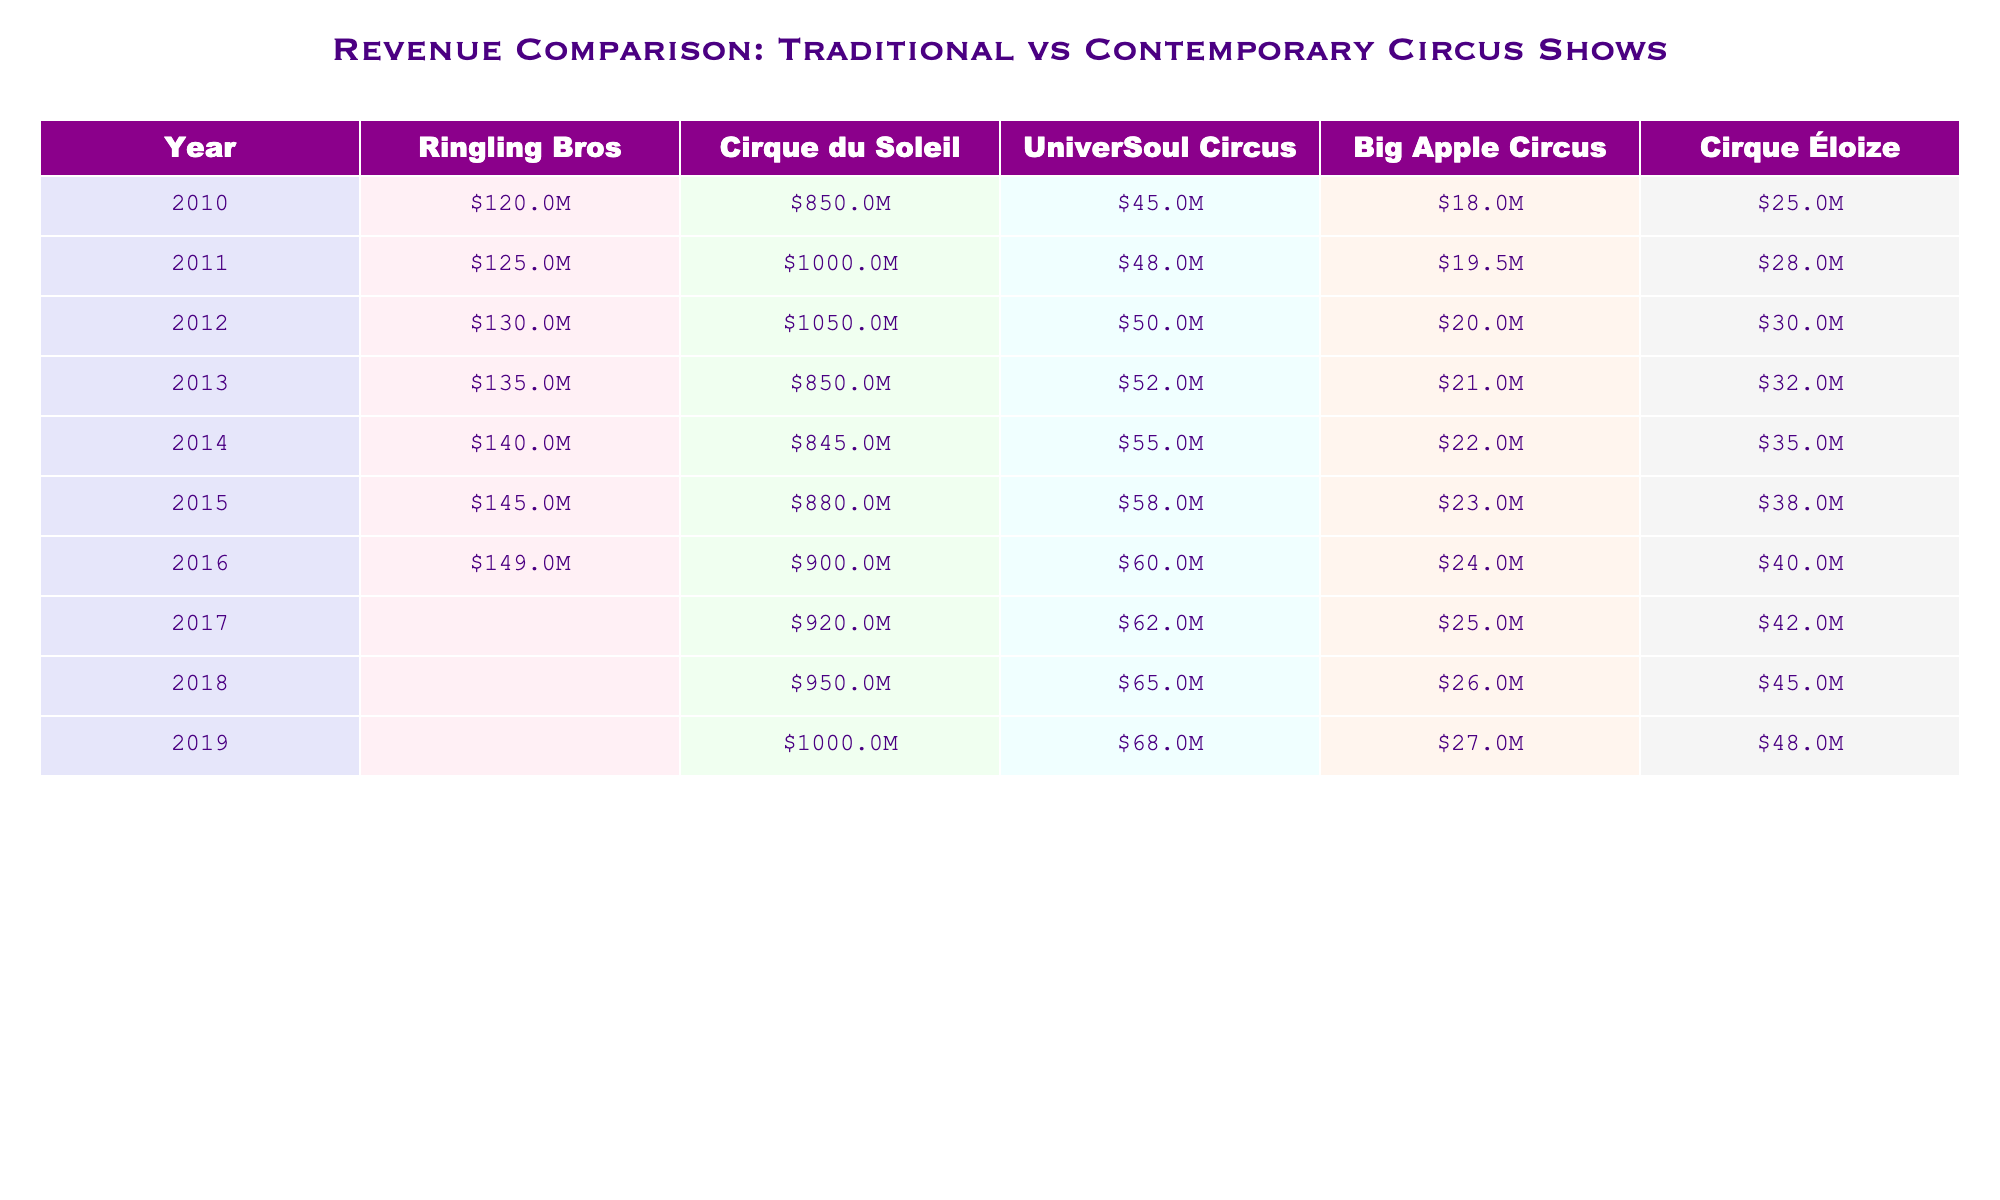What was the revenue of Cirque du Soleil in 2015? From the table, we can locate the row for the year 2015, which shows that Cirque du Soleil had a revenue of $880 million.
Answer: $880 million What is the total revenue for Universoul Circus from 2010 to 2014? Adding the values for Universoul Circus from 2010 to 2014, we get $45,000,000 + $48,000,000 + $50,000,000 + $55,000,000 = $198,000,000.
Answer: $198 million Was the revenue for Ringling Bros. non-existent in 2017? The table shows a value of 0 for Ringling Bros. in 2017, confirming that the revenue was indeed non-existent that year.
Answer: Yes Which year had the highest revenue for Big Apple Circus? Referring to the table, we check the revenue for Big Apple Circus across the years, and the highest value is $27,000,000 in 2019.
Answer: 2019 Calculate the average revenue of Cirque Éloize from 2010 to 2016. The revenues for Cirque Éloize from 2010 to 2016 are $25,000,000, $28,000,000, $30,000,000, $32,000,000, $35,000,000, and $40,000,000. The sum is $25M + $28M + $30M + $32M + $35M + $40M = $190M. Dividing by 7 gives an average of $190M/7 = approximately $27.14M.
Answer: $32 million What revenue difference was observed between Cirque du Soleil and Ringling Bros in 2014? In 2014, Cirque du Soleil had a revenue of $845,000,000, and Ringling Bros had $140,000,000. The difference can be calculated as $845M - $140M = $705M.
Answer: $705 million In which year did Universoul Circus first exceed $50 million in revenue? By examining the table, Universoul Circus exceeded $50 million for the first time in 2012 when the revenue was $50 million.
Answer: 2012 How much more revenue did Cirque du Soleil generate than Big Apple Circus in 2013? In 2013, Cirque du Soleil earned $850 million and Big Apple Circus $21 million. The difference is $850M - $21M = $829 million.
Answer: $829 million Which circus had the lowest revenue in 2011? Looking through the numbers for 2011, we find Ringling Bros. with $125,000,000, Cirque du Soleil with $1,000,000,000, UniverSoul Circus with $48,000,000, Big Apple Circus with $19,500,000, and Cirque Éloize with $28,000,000. Universoul Circus had the lowest revenue.
Answer: UniverSoul Circus 